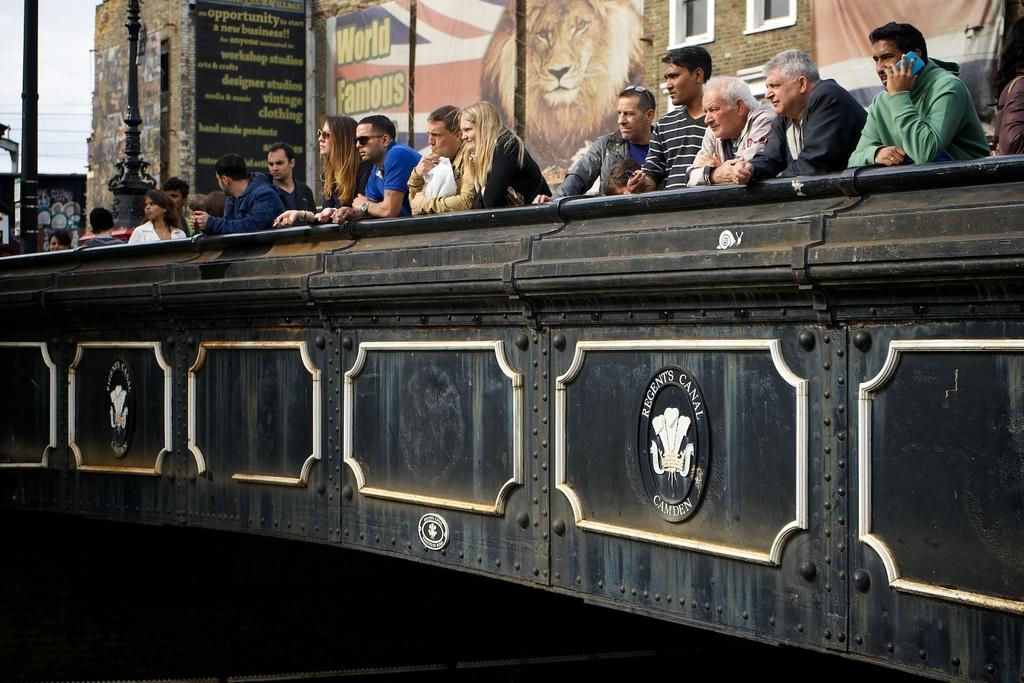<image>
Present a compact description of the photo's key features. People stand on a black bridge that says Regent's Canal Camden on ti. 